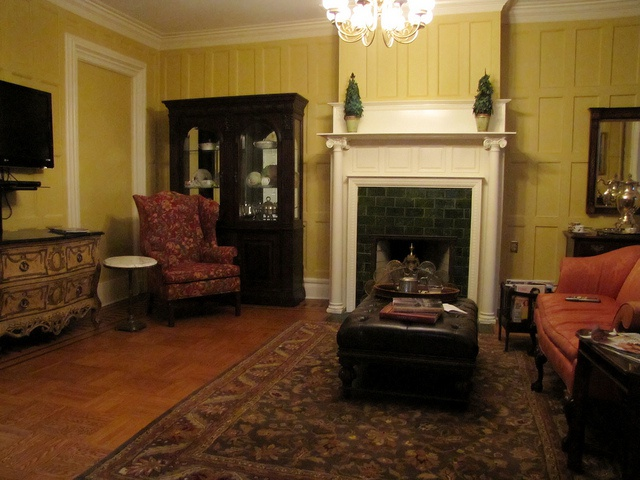Describe the objects in this image and their specific colors. I can see chair in olive, maroon, black, and brown tones, couch in olive, maroon, brown, and black tones, tv in olive, black, and maroon tones, vase in olive, maroon, black, and gray tones, and potted plant in olive, black, darkgreen, and tan tones in this image. 